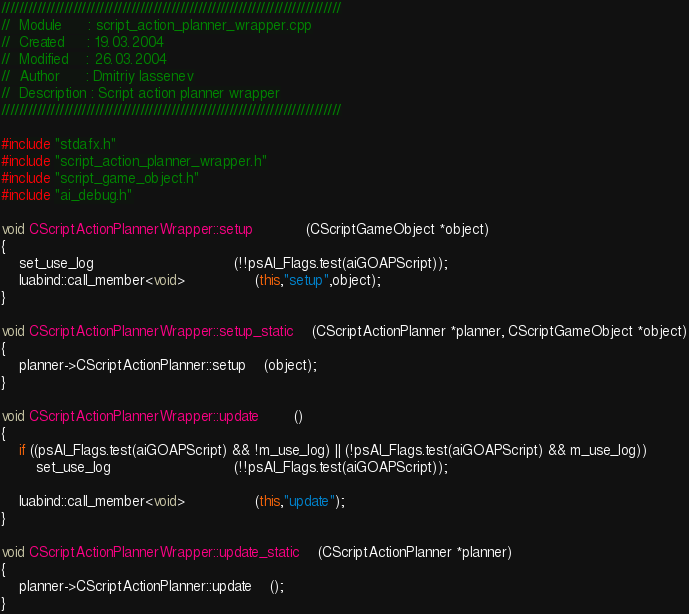Convert code to text. <code><loc_0><loc_0><loc_500><loc_500><_C++_>////////////////////////////////////////////////////////////////////////////
//	Module 		: script_action_planner_wrapper.cpp
//	Created 	: 19.03.2004
//  Modified 	: 26.03.2004
//	Author		: Dmitriy Iassenev
//	Description : Script action planner wrapper
////////////////////////////////////////////////////////////////////////////

#include "stdafx.h"
#include "script_action_planner_wrapper.h"
#include "script_game_object.h"
#include "ai_debug.h"

void CScriptActionPlannerWrapper::setup			(CScriptGameObject *object)
{
	set_use_log								(!!psAI_Flags.test(aiGOAPScript));
	luabind::call_member<void>				(this,"setup",object);
}

void CScriptActionPlannerWrapper::setup_static	(CScriptActionPlanner *planner, CScriptGameObject *object)
{
	planner->CScriptActionPlanner::setup	(object);
}

void CScriptActionPlannerWrapper::update		()
{
	if ((psAI_Flags.test(aiGOAPScript) && !m_use_log) || (!psAI_Flags.test(aiGOAPScript) && m_use_log))
		set_use_log							(!!psAI_Flags.test(aiGOAPScript));

	luabind::call_member<void>				(this,"update");
}

void CScriptActionPlannerWrapper::update_static	(CScriptActionPlanner *planner)
{
	planner->CScriptActionPlanner::update	();
}
</code> 